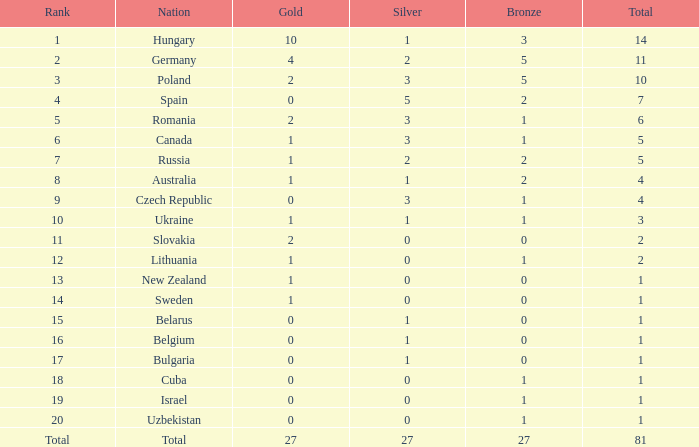Which bronze medal, with 2 golds and a slovakian nation, has a total exceeding 2? None. 